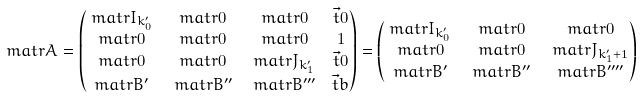Convert formula to latex. <formula><loc_0><loc_0><loc_500><loc_500>\ m a t r { A } & = \begin{pmatrix} \ m a t r { I } _ { k ^ { \prime } _ { 0 } } & \ m a t r { 0 } & \ m a t r { 0 } & \vec { t } { 0 } \\ \ m a t r { 0 } & \ m a t r { 0 } & \ m a t r { 0 } & 1 \\ \ m a t r { 0 } & \ m a t r { 0 } & \ m a t r { J } _ { k ^ { \prime } _ { 1 } } & \vec { t } { 0 } \\ \ m a t r { B } ^ { \prime } & \ m a t r { B } ^ { \prime \prime } & \ m a t r { B } ^ { \prime \prime \prime } & \vec { t } { b } \end{pmatrix} = \begin{pmatrix} \ m a t r { I } _ { k ^ { \prime } _ { 0 } } & \ m a t r { 0 } & \ m a t r { 0 } \\ \ m a t r { 0 } & \ m a t r { 0 } & \ m a t r { J } _ { k ^ { \prime } _ { 1 } + 1 } \\ \ m a t r { B } ^ { \prime } & \ m a t r { B } ^ { \prime \prime } & \ m a t r { B } ^ { \prime \prime \prime \prime } \end{pmatrix}</formula> 